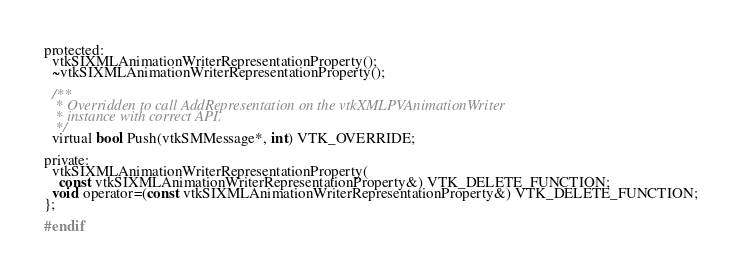<code> <loc_0><loc_0><loc_500><loc_500><_C_>protected:
  vtkSIXMLAnimationWriterRepresentationProperty();
  ~vtkSIXMLAnimationWriterRepresentationProperty();

  /**
   * Overridden to call AddRepresentation on the vtkXMLPVAnimationWriter
   * instance with correct API.
   */
  virtual bool Push(vtkSMMessage*, int) VTK_OVERRIDE;

private:
  vtkSIXMLAnimationWriterRepresentationProperty(
    const vtkSIXMLAnimationWriterRepresentationProperty&) VTK_DELETE_FUNCTION;
  void operator=(const vtkSIXMLAnimationWriterRepresentationProperty&) VTK_DELETE_FUNCTION;
};

#endif
</code> 